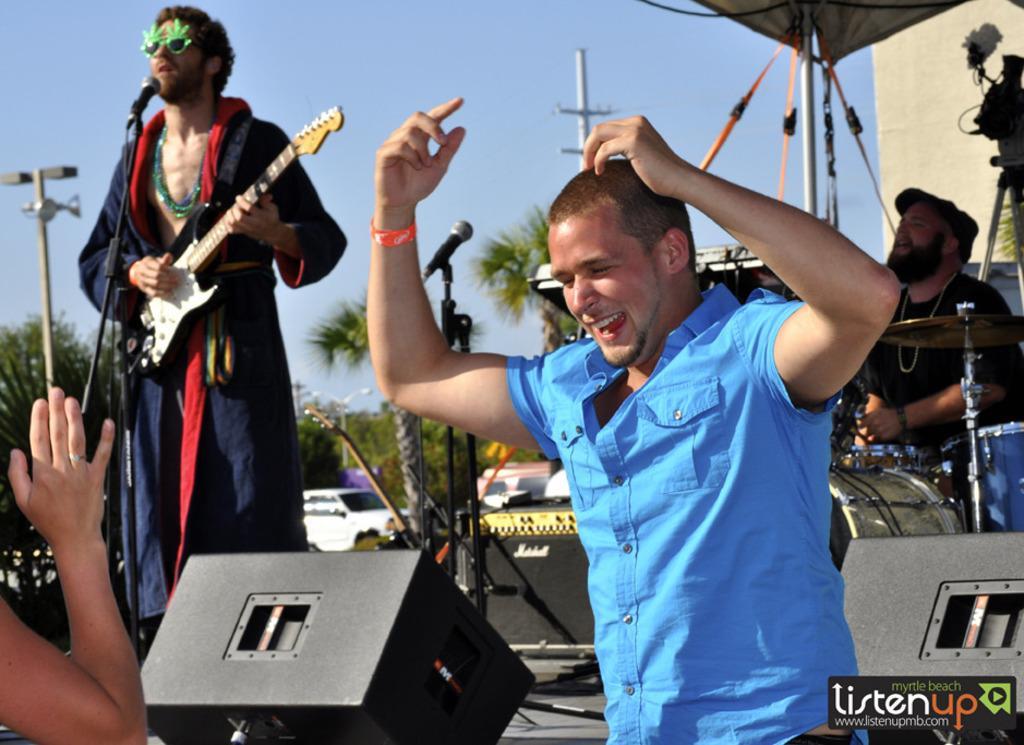Describe this image in one or two sentences. In this image we can see this person wearing blue shirt is standing and smiling. This person is standing on the stage and playing guitar. This person is playing electronic drums. In the background we can see car, trees and sky. 